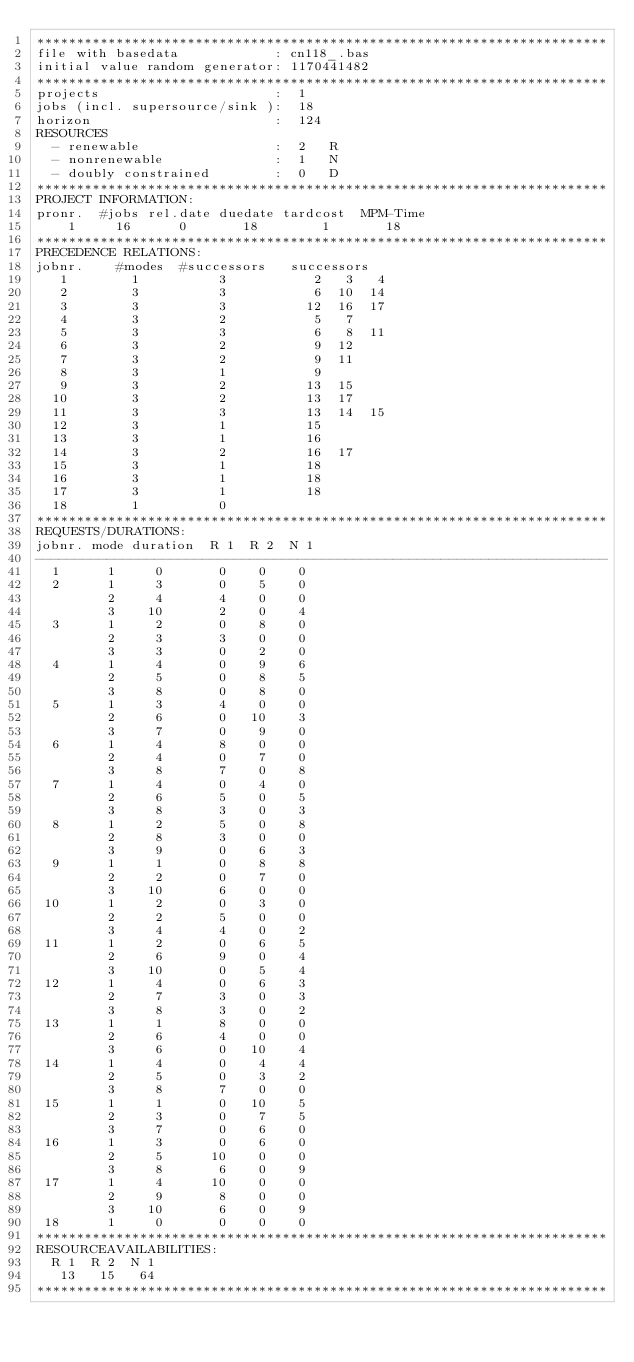<code> <loc_0><loc_0><loc_500><loc_500><_ObjectiveC_>************************************************************************
file with basedata            : cn118_.bas
initial value random generator: 1170441482
************************************************************************
projects                      :  1
jobs (incl. supersource/sink ):  18
horizon                       :  124
RESOURCES
  - renewable                 :  2   R
  - nonrenewable              :  1   N
  - doubly constrained        :  0   D
************************************************************************
PROJECT INFORMATION:
pronr.  #jobs rel.date duedate tardcost  MPM-Time
    1     16      0       18        1       18
************************************************************************
PRECEDENCE RELATIONS:
jobnr.    #modes  #successors   successors
   1        1          3           2   3   4
   2        3          3           6  10  14
   3        3          3          12  16  17
   4        3          2           5   7
   5        3          3           6   8  11
   6        3          2           9  12
   7        3          2           9  11
   8        3          1           9
   9        3          2          13  15
  10        3          2          13  17
  11        3          3          13  14  15
  12        3          1          15
  13        3          1          16
  14        3          2          16  17
  15        3          1          18
  16        3          1          18
  17        3          1          18
  18        1          0        
************************************************************************
REQUESTS/DURATIONS:
jobnr. mode duration  R 1  R 2  N 1
------------------------------------------------------------------------
  1      1     0       0    0    0
  2      1     3       0    5    0
         2     4       4    0    0
         3    10       2    0    4
  3      1     2       0    8    0
         2     3       3    0    0
         3     3       0    2    0
  4      1     4       0    9    6
         2     5       0    8    5
         3     8       0    8    0
  5      1     3       4    0    0
         2     6       0   10    3
         3     7       0    9    0
  6      1     4       8    0    0
         2     4       0    7    0
         3     8       7    0    8
  7      1     4       0    4    0
         2     6       5    0    5
         3     8       3    0    3
  8      1     2       5    0    8
         2     8       3    0    0
         3     9       0    6    3
  9      1     1       0    8    8
         2     2       0    7    0
         3    10       6    0    0
 10      1     2       0    3    0
         2     2       5    0    0
         3     4       4    0    2
 11      1     2       0    6    5
         2     6       9    0    4
         3    10       0    5    4
 12      1     4       0    6    3
         2     7       3    0    3
         3     8       3    0    2
 13      1     1       8    0    0
         2     6       4    0    0
         3     6       0   10    4
 14      1     4       0    4    4
         2     5       0    3    2
         3     8       7    0    0
 15      1     1       0   10    5
         2     3       0    7    5
         3     7       0    6    0
 16      1     3       0    6    0
         2     5      10    0    0
         3     8       6    0    9
 17      1     4      10    0    0
         2     9       8    0    0
         3    10       6    0    9
 18      1     0       0    0    0
************************************************************************
RESOURCEAVAILABILITIES:
  R 1  R 2  N 1
   13   15   64
************************************************************************
</code> 